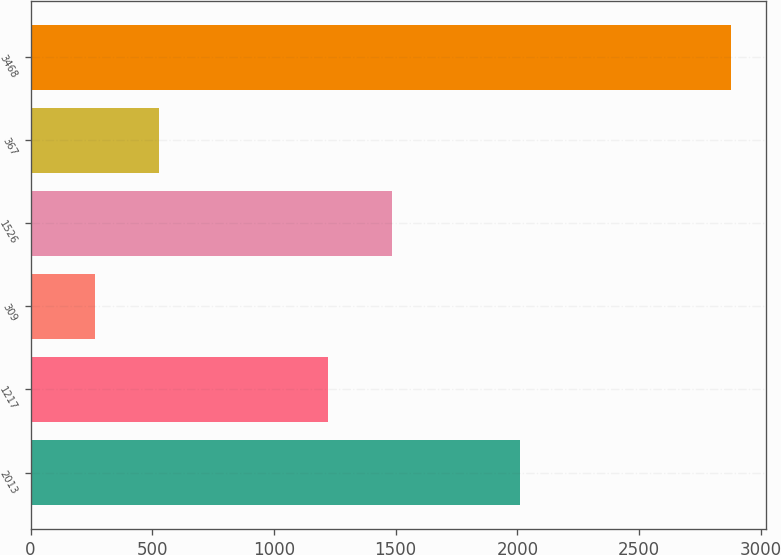Convert chart. <chart><loc_0><loc_0><loc_500><loc_500><bar_chart><fcel>2013<fcel>1217<fcel>309<fcel>1526<fcel>367<fcel>3468<nl><fcel>2012<fcel>1220<fcel>265<fcel>1485<fcel>526.4<fcel>2879<nl></chart> 